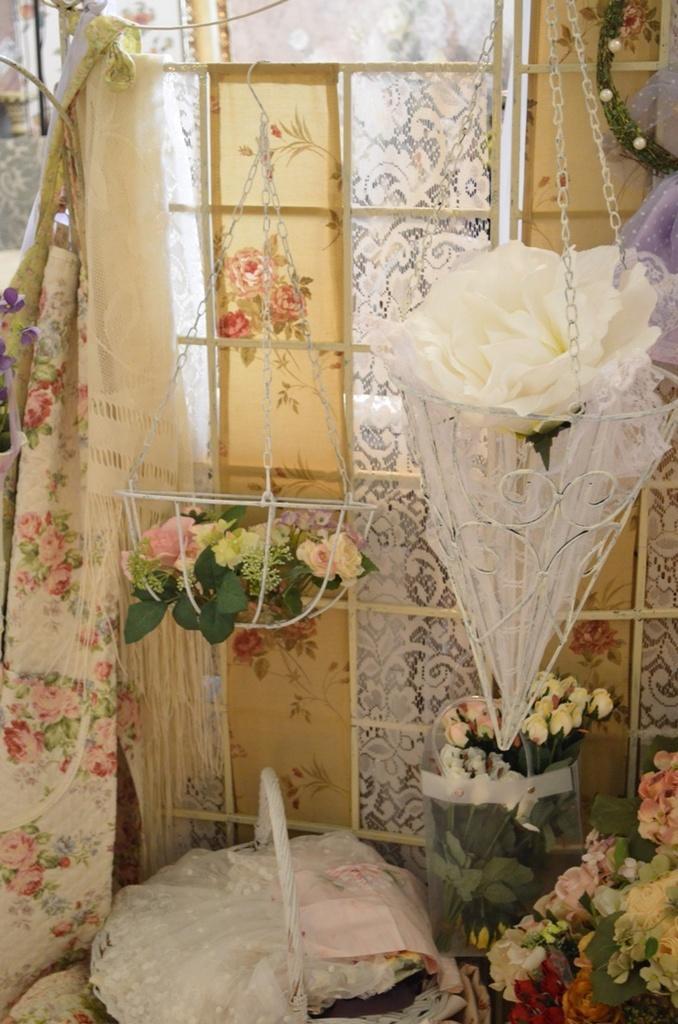In one or two sentences, can you explain what this image depicts? In this image I can see there are flowers in the baskets and other things. On the left side there are clothes. 